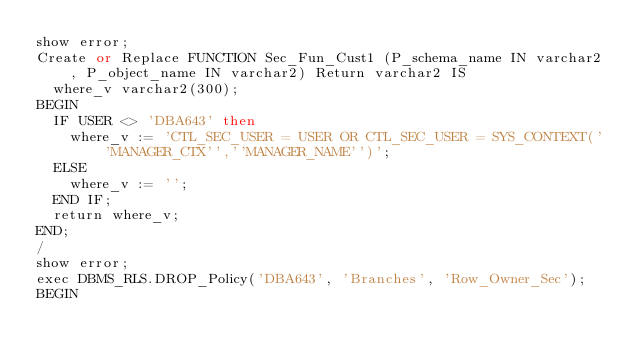<code> <loc_0><loc_0><loc_500><loc_500><_SQL_>show error;
Create or Replace FUNCTION Sec_Fun_Cust1 (P_schema_name IN varchar2, P_object_name IN varchar2) Return varchar2 IS
  where_v varchar2(300);
BEGIN
  IF USER <> 'DBA643' then
    where_v := 'CTL_SEC_USER = USER OR CTL_SEC_USER = SYS_CONTEXT(''MANAGER_CTX'',''MANAGER_NAME'')';
  ELSE
    where_v := '';
  END IF; 
  return where_v;
END;
/
show error;
exec DBMS_RLS.DROP_Policy('DBA643', 'Branches', 'Row_Owner_Sec');
BEGIN</code> 